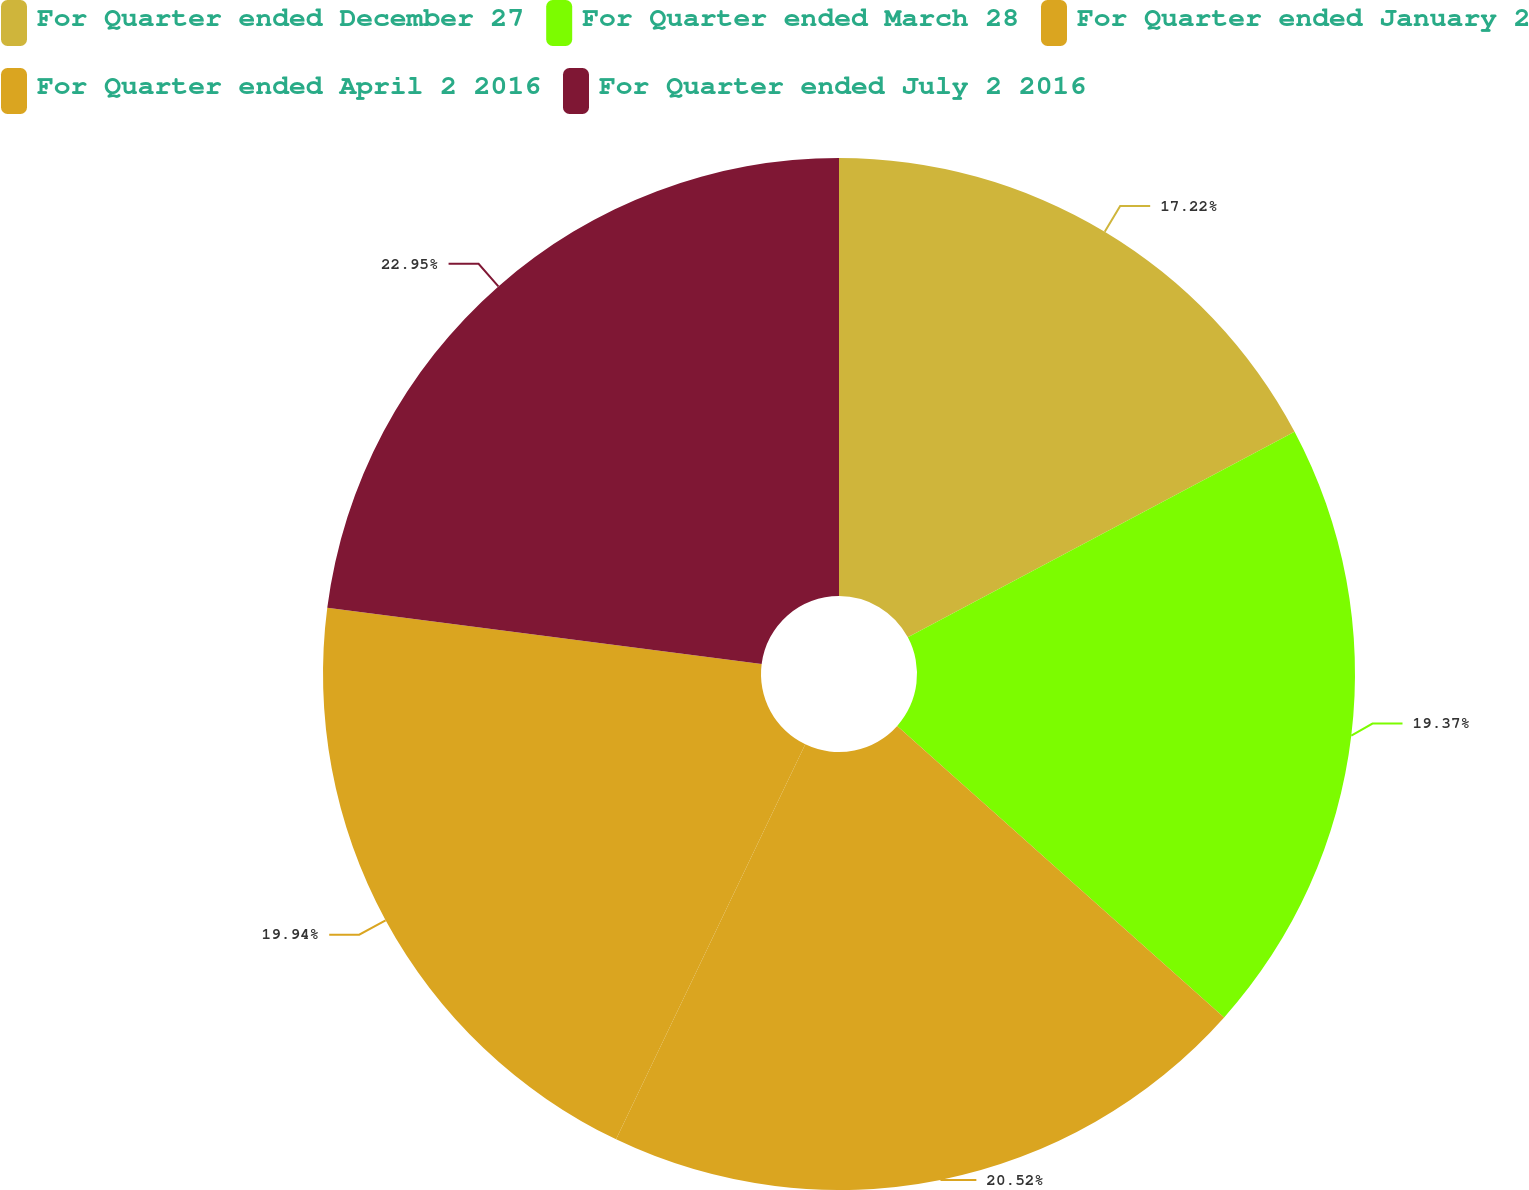Convert chart to OTSL. <chart><loc_0><loc_0><loc_500><loc_500><pie_chart><fcel>For Quarter ended December 27<fcel>For Quarter ended March 28<fcel>For Quarter ended January 2<fcel>For Quarter ended April 2 2016<fcel>For Quarter ended July 2 2016<nl><fcel>17.22%<fcel>19.37%<fcel>20.52%<fcel>19.94%<fcel>22.95%<nl></chart> 